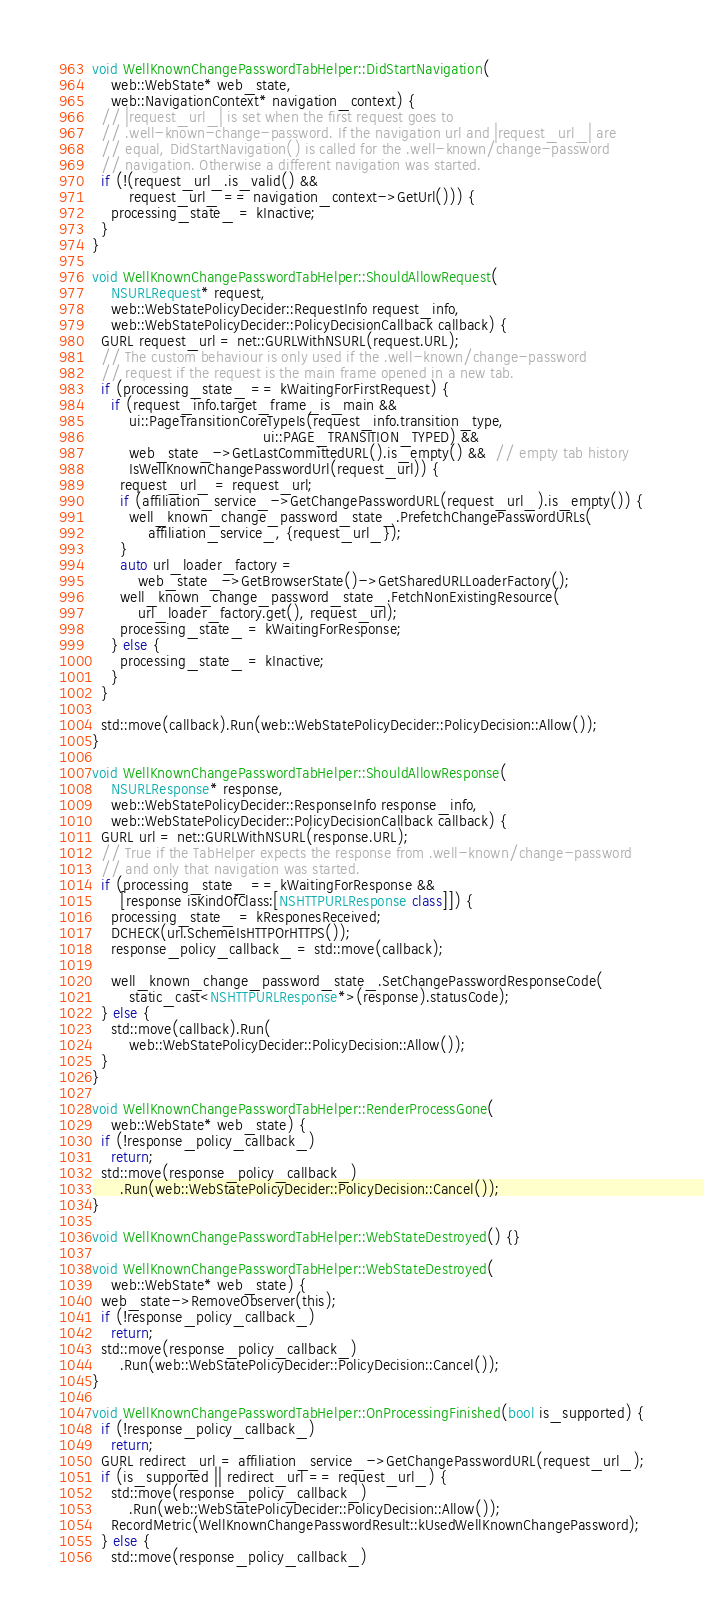<code> <loc_0><loc_0><loc_500><loc_500><_ObjectiveC_>void WellKnownChangePasswordTabHelper::DidStartNavigation(
    web::WebState* web_state,
    web::NavigationContext* navigation_context) {
  // |request_url_| is set when the first request goes to
  // .well-known-change-password. If the navigation url and |request_url_| are
  // equal, DidStartNavigation() is called for the .well-known/change-password
  // navigation. Otherwise a different navigation was started.
  if (!(request_url_.is_valid() &&
        request_url_ == navigation_context->GetUrl())) {
    processing_state_ = kInactive;
  }
}

void WellKnownChangePasswordTabHelper::ShouldAllowRequest(
    NSURLRequest* request,
    web::WebStatePolicyDecider::RequestInfo request_info,
    web::WebStatePolicyDecider::PolicyDecisionCallback callback) {
  GURL request_url = net::GURLWithNSURL(request.URL);
  // The custom behaviour is only used if the .well-known/change-password
  // request if the request is the main frame opened in a new tab.
  if (processing_state_ == kWaitingForFirstRequest) {
    if (request_info.target_frame_is_main &&
        ui::PageTransitionCoreTypeIs(request_info.transition_type,
                                     ui::PAGE_TRANSITION_TYPED) &&
        web_state_->GetLastCommittedURL().is_empty() &&  // empty tab history
        IsWellKnownChangePasswordUrl(request_url)) {
      request_url_ = request_url;
      if (affiliation_service_->GetChangePasswordURL(request_url_).is_empty()) {
        well_known_change_password_state_.PrefetchChangePasswordURLs(
            affiliation_service_, {request_url_});
      }
      auto url_loader_factory =
          web_state_->GetBrowserState()->GetSharedURLLoaderFactory();
      well_known_change_password_state_.FetchNonExistingResource(
          url_loader_factory.get(), request_url);
      processing_state_ = kWaitingForResponse;
    } else {
      processing_state_ = kInactive;
    }
  }

  std::move(callback).Run(web::WebStatePolicyDecider::PolicyDecision::Allow());
}

void WellKnownChangePasswordTabHelper::ShouldAllowResponse(
    NSURLResponse* response,
    web::WebStatePolicyDecider::ResponseInfo response_info,
    web::WebStatePolicyDecider::PolicyDecisionCallback callback) {
  GURL url = net::GURLWithNSURL(response.URL);
  // True if the TabHelper expects the response from .well-known/change-password
  // and only that navigation was started.
  if (processing_state_ == kWaitingForResponse &&
      [response isKindOfClass:[NSHTTPURLResponse class]]) {
    processing_state_ = kResponesReceived;
    DCHECK(url.SchemeIsHTTPOrHTTPS());
    response_policy_callback_ = std::move(callback);

    well_known_change_password_state_.SetChangePasswordResponseCode(
        static_cast<NSHTTPURLResponse*>(response).statusCode);
  } else {
    std::move(callback).Run(
        web::WebStatePolicyDecider::PolicyDecision::Allow());
  }
}

void WellKnownChangePasswordTabHelper::RenderProcessGone(
    web::WebState* web_state) {
  if (!response_policy_callback_)
    return;
  std::move(response_policy_callback_)
      .Run(web::WebStatePolicyDecider::PolicyDecision::Cancel());
}

void WellKnownChangePasswordTabHelper::WebStateDestroyed() {}

void WellKnownChangePasswordTabHelper::WebStateDestroyed(
    web::WebState* web_state) {
  web_state->RemoveObserver(this);
  if (!response_policy_callback_)
    return;
  std::move(response_policy_callback_)
      .Run(web::WebStatePolicyDecider::PolicyDecision::Cancel());
}

void WellKnownChangePasswordTabHelper::OnProcessingFinished(bool is_supported) {
  if (!response_policy_callback_)
    return;
  GURL redirect_url = affiliation_service_->GetChangePasswordURL(request_url_);
  if (is_supported || redirect_url == request_url_) {
    std::move(response_policy_callback_)
        .Run(web::WebStatePolicyDecider::PolicyDecision::Allow());
    RecordMetric(WellKnownChangePasswordResult::kUsedWellKnownChangePassword);
  } else {
    std::move(response_policy_callback_)</code> 